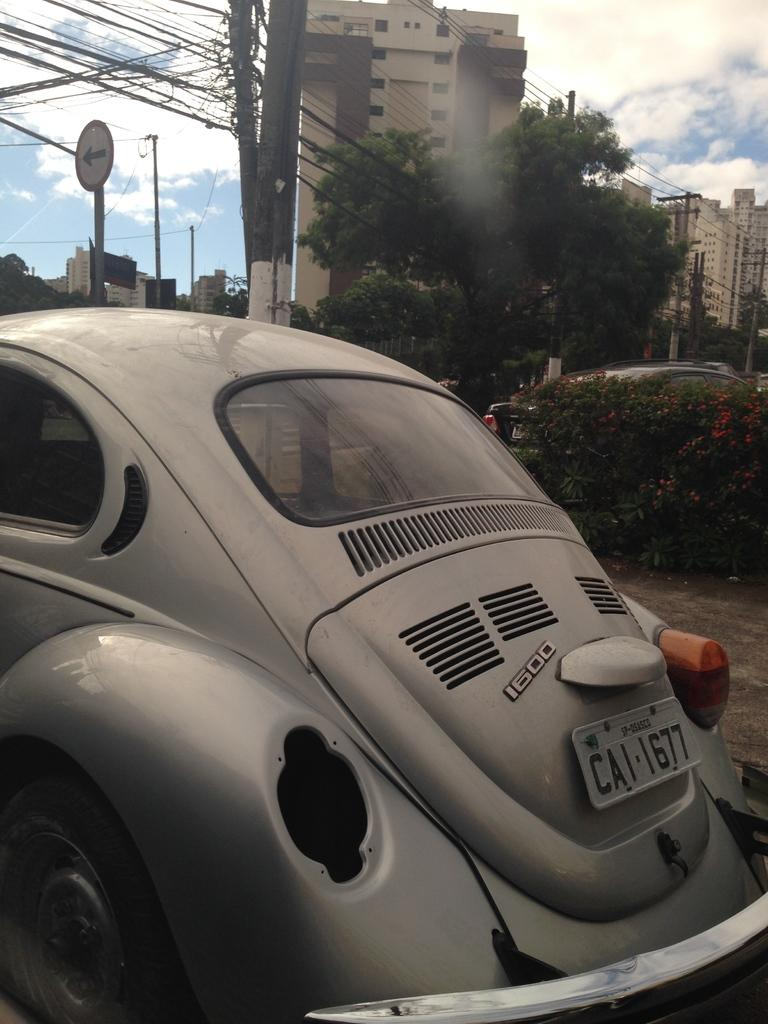What types of objects can be seen in the image? There are vehicles, plants, poles, trees, buildings, and a board in the image. Can you describe the natural elements in the image? There are plants and trees in the image. What structures are present in the image? There are poles and buildings in the image. What is the board used for in the image? The purpose of the board in the image cannot be determined from the provided facts. What is visible in the background of the image? The sky is visible in the background of the image, with clouds present. Can you tell me how many roses are on the board in the image? There is no rose present on the board in the image; only a board is mentioned. What type of net is used to catch the vehicles in the image? There is no net present in the image, and vehicles are not being caught. 